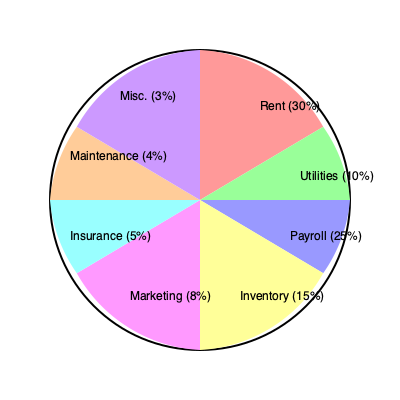Your late husband's business had total monthly expenses of $20,000. Based on the pie chart of business expenses, how much money was spent on Payroll and Inventory combined? To solve this problem, we need to follow these steps:

1. Identify the percentages for Payroll and Inventory from the pie chart:
   - Payroll: 25%
   - Inventory: 15%

2. Add these percentages together:
   $25\% + 15\% = 40\%$

3. Convert the percentage to a decimal:
   $40\% = 0.40$

4. Multiply the total monthly expenses by this decimal:
   $\$20,000 \times 0.40 = \$8,000$

Therefore, the amount spent on Payroll and Inventory combined is $8,000.
Answer: $8,000 